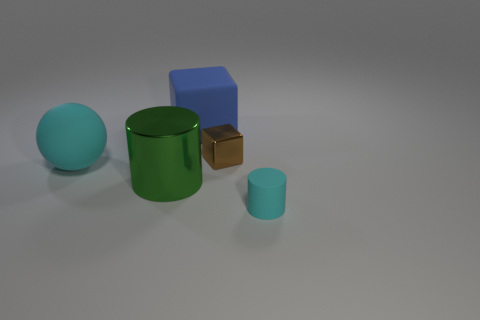What material is the large object that is left of the green shiny cylinder that is in front of the small brown cube right of the large blue rubber cube?
Make the answer very short. Rubber. There is another thing that is the same material as the green object; what color is it?
Provide a short and direct response. Brown. There is a cyan matte thing right of the tiny object behind the big ball; how many cyan rubber things are behind it?
Your answer should be compact. 1. Is there any other thing that has the same shape as the large cyan object?
Offer a very short reply. No. How many objects are tiny things behind the rubber cylinder or cyan cubes?
Your answer should be very brief. 1. There is a rubber object on the right side of the matte block; is it the same color as the big sphere?
Your answer should be very brief. Yes. The cyan object that is to the left of the blue rubber block on the right side of the big green metallic thing is what shape?
Your response must be concise. Sphere. Is the number of large blue cubes that are to the left of the large cyan rubber ball less than the number of large cyan objects right of the large green metallic thing?
Offer a very short reply. No. What is the size of the brown shiny object that is the same shape as the large blue matte object?
Keep it short and to the point. Small. How many things are big cyan objects that are to the left of the big green cylinder or large matte things in front of the big blue block?
Your answer should be very brief. 1. 